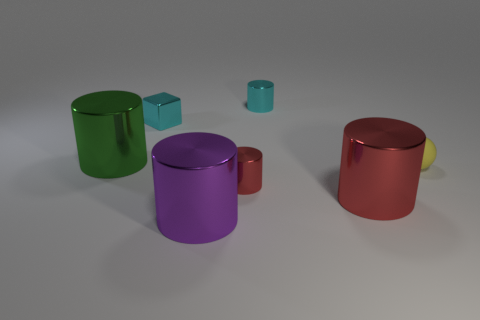Subtract all small cylinders. How many cylinders are left? 3 Subtract all purple cylinders. How many cylinders are left? 4 Subtract all cubes. How many objects are left? 6 Add 3 green matte cylinders. How many objects exist? 10 Subtract 1 balls. How many balls are left? 0 Subtract all red spheres. How many red cylinders are left? 2 Subtract all purple blocks. Subtract all green cylinders. How many blocks are left? 1 Subtract all purple balls. Subtract all large purple cylinders. How many objects are left? 6 Add 4 cylinders. How many cylinders are left? 9 Add 1 purple blocks. How many purple blocks exist? 1 